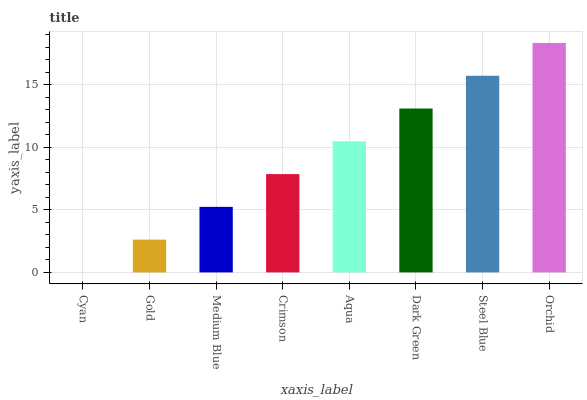Is Cyan the minimum?
Answer yes or no. Yes. Is Orchid the maximum?
Answer yes or no. Yes. Is Gold the minimum?
Answer yes or no. No. Is Gold the maximum?
Answer yes or no. No. Is Gold greater than Cyan?
Answer yes or no. Yes. Is Cyan less than Gold?
Answer yes or no. Yes. Is Cyan greater than Gold?
Answer yes or no. No. Is Gold less than Cyan?
Answer yes or no. No. Is Aqua the high median?
Answer yes or no. Yes. Is Crimson the low median?
Answer yes or no. Yes. Is Gold the high median?
Answer yes or no. No. Is Gold the low median?
Answer yes or no. No. 